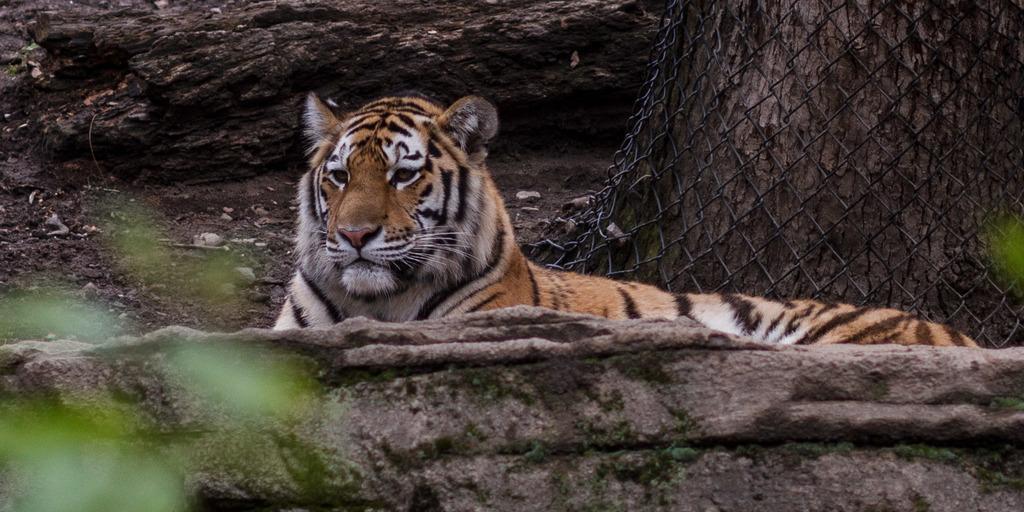Describe this image in one or two sentences. In this picture I can observe a tiger sitting on the ground. In the background I can observe an open land. On the right side there is a tree. 